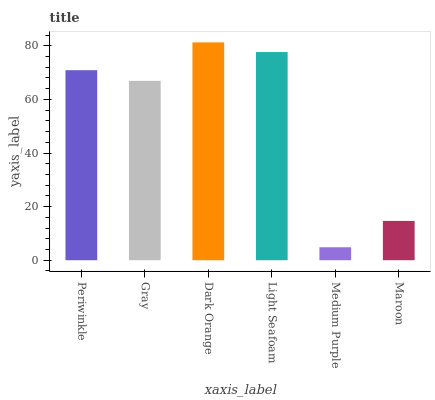Is Medium Purple the minimum?
Answer yes or no. Yes. Is Dark Orange the maximum?
Answer yes or no. Yes. Is Gray the minimum?
Answer yes or no. No. Is Gray the maximum?
Answer yes or no. No. Is Periwinkle greater than Gray?
Answer yes or no. Yes. Is Gray less than Periwinkle?
Answer yes or no. Yes. Is Gray greater than Periwinkle?
Answer yes or no. No. Is Periwinkle less than Gray?
Answer yes or no. No. Is Periwinkle the high median?
Answer yes or no. Yes. Is Gray the low median?
Answer yes or no. Yes. Is Medium Purple the high median?
Answer yes or no. No. Is Maroon the low median?
Answer yes or no. No. 